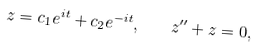<formula> <loc_0><loc_0><loc_500><loc_500>z = c _ { 1 } e ^ { i t } + c _ { 2 } e ^ { - i t } , \quad z ^ { \prime \prime } + z = 0 ,</formula> 